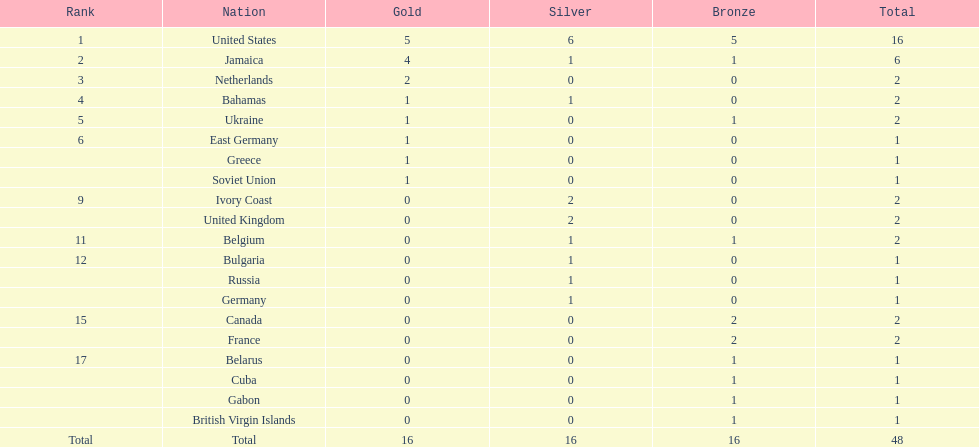How many countries have managed to secure at least two gold medals? 3. Can you give me this table as a dict? {'header': ['Rank', 'Nation', 'Gold', 'Silver', 'Bronze', 'Total'], 'rows': [['1', 'United States', '5', '6', '5', '16'], ['2', 'Jamaica', '4', '1', '1', '6'], ['3', 'Netherlands', '2', '0', '0', '2'], ['4', 'Bahamas', '1', '1', '0', '2'], ['5', 'Ukraine', '1', '0', '1', '2'], ['6', 'East Germany', '1', '0', '0', '1'], ['', 'Greece', '1', '0', '0', '1'], ['', 'Soviet Union', '1', '0', '0', '1'], ['9', 'Ivory Coast', '0', '2', '0', '2'], ['', 'United Kingdom', '0', '2', '0', '2'], ['11', 'Belgium', '0', '1', '1', '2'], ['12', 'Bulgaria', '0', '1', '0', '1'], ['', 'Russia', '0', '1', '0', '1'], ['', 'Germany', '0', '1', '0', '1'], ['15', 'Canada', '0', '0', '2', '2'], ['', 'France', '0', '0', '2', '2'], ['17', 'Belarus', '0', '0', '1', '1'], ['', 'Cuba', '0', '0', '1', '1'], ['', 'Gabon', '0', '0', '1', '1'], ['', 'British Virgin Islands', '0', '0', '1', '1'], ['Total', 'Total', '16', '16', '16', '48']]} 